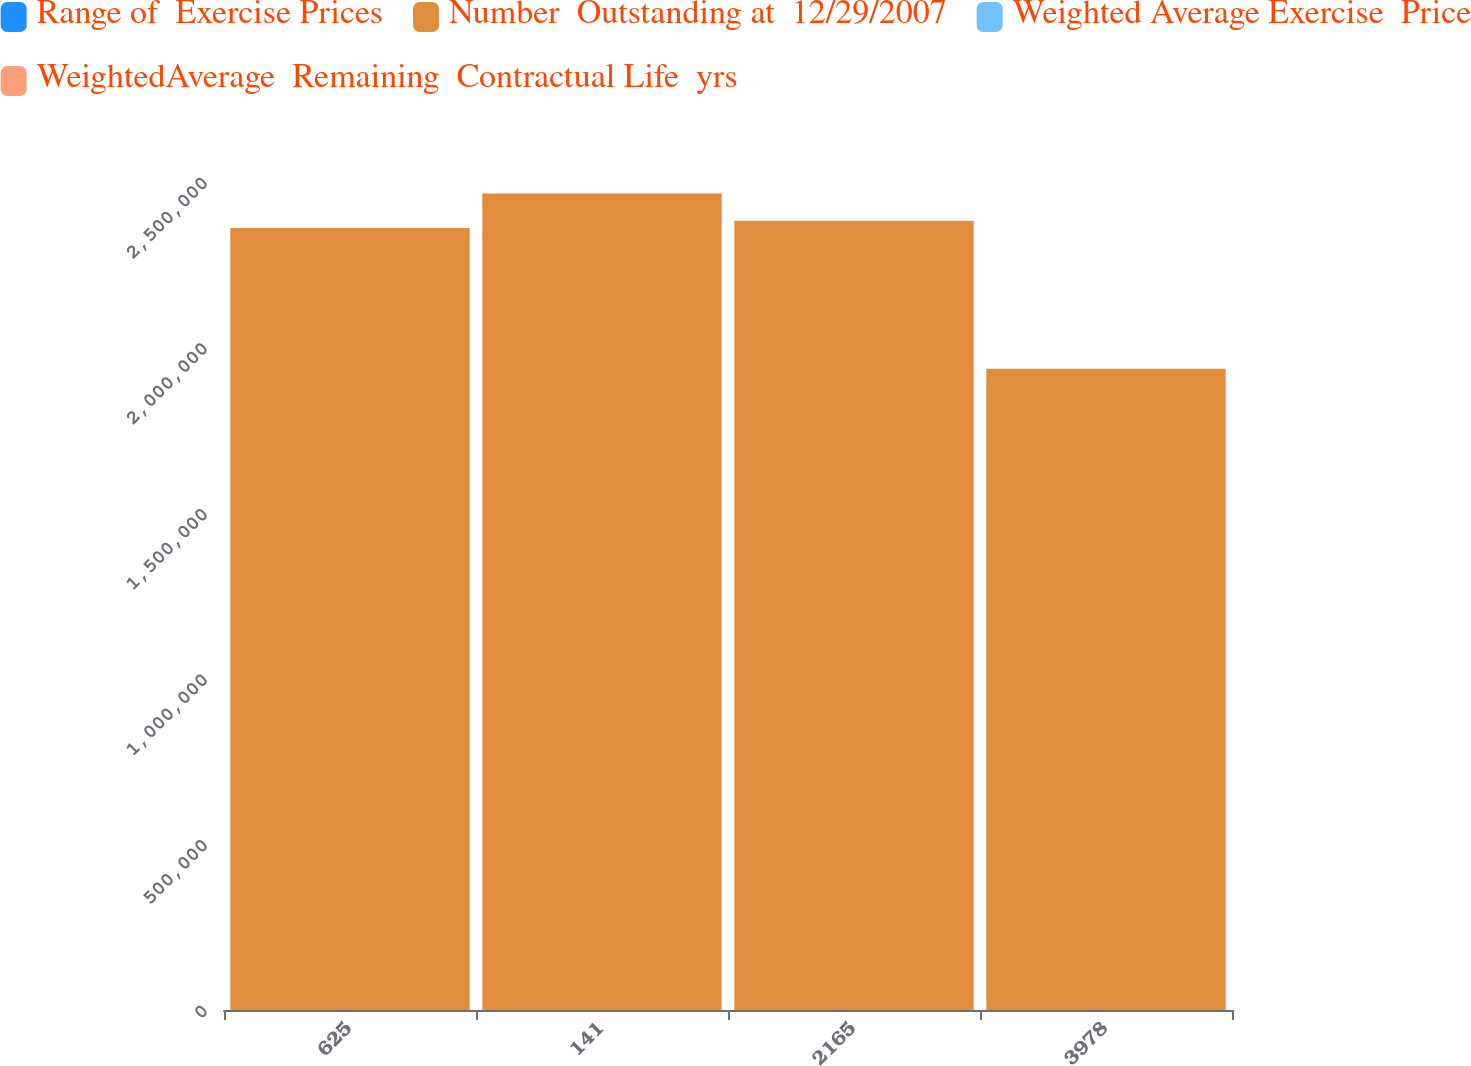<chart> <loc_0><loc_0><loc_500><loc_500><stacked_bar_chart><ecel><fcel>625<fcel>141<fcel>2165<fcel>3978<nl><fcel>Range of  Exercise Prices<fcel>14<fcel>21.64<fcel>39.29<fcel>136.86<nl><fcel>Number  Outstanding at  12/29/2007<fcel>2.36113e+06<fcel>2.46538e+06<fcel>2.38314e+06<fcel>1.93592e+06<nl><fcel>Weighted Average Exercise  Price<fcel>6.15<fcel>7.05<fcel>6.1<fcel>8.77<nl><fcel>WeightedAverage  Remaining  Contractual Life  yrs<fcel>10.16<fcel>18.07<fcel>27.65<fcel>48.37<nl></chart> 